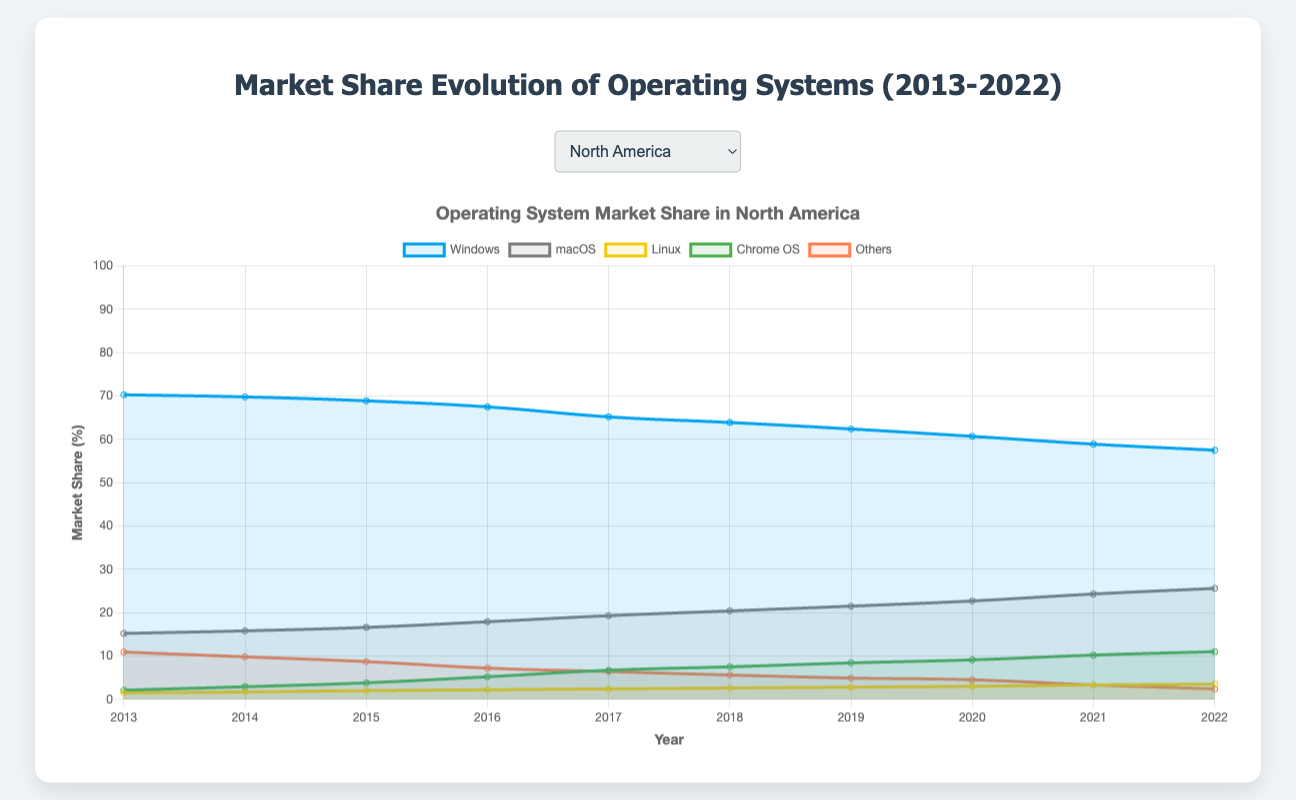What is the overall trend for Windows market share in North America from 2013 to 2022? The Windows market share in North America shows a consistent decline over the years. Starting at 70.3% in 2013 and decreasing to 57.5% in 2022. This indicates an overall downward trend.
Answer: Downward Which region had the highest market share for macOS in 2022? To find the region with the highest macOS market share in 2022, we compare the values across regions: North America (25.6%), Europe (18.9%), Asia-Pacific (9.7%), Latin America (13.1%), and Middle East & Africa (10.5%). North America has the highest share.
Answer: North America Compare the market share of Chrome OS in North America and Europe in 2017. Which region has a higher share? Chrome OS in North America has a market share of 6.7% in 2017, while Europe has a market share of 3.3%. Thus, North America has a higher share.
Answer: North America What is the combined market share of Linux and macOS in Asia-Pacific in 2022? Linux has a market share of 3.9% and macOS has 9.7% in Asia-Pacific for 2022. Adding these together gives 3.9% + 9.7% = 13.6%.
Answer: 13.6% Which operating system had the largest increase in market share in North America from 2013 to 2022? Comparing the market share changes for each OS in North America from 2013 to 2022: Windows (-12.8%), macOS (+10.4%), Linux (+2.0%), Chrome OS (+8.9%), Others (-8.5%). macOS saw the largest increase.
Answer: macOS In 2022, at what rate has the "Others" category decreased in North America compared to 2013? "Others" had a market share of 10.9% in 2013 and 2.4% in 2022 in North America. The decrease is 10.9% - 2.4% = 8.5%.
Answer: 8.5% Which operating system had the most stable market share (least change) in Latin America from 2013 to 2022? By calculating the differences for each OS in Latin America from 2013 to 2022: Windows (-13.4%), Linux (+2.9%), macOS (+7.1%), Chrome OS (+6.1%), Others (-2.7%). Linux had the smallest change (+2.9%).
Answer: Linux Compare the trend of Windows market share in Asia-Pacific and Europe from 2013 to 2022. What is common? Both Asia-Pacific and Europe show a declining trend for Windows market share from 2013 to 2022. In Asia-Pacific, it decreased from 80.6% to 63.0%, and in Europe, it decreased from 75.1% to 62.1%. The commonality is the downward trend.
Answer: Downward trend What is the difference in market share between Windows and Android in Asia-Pacific in 2022? The market share of Windows in Asia-Pacific in 2022 is 63.0% and for Android, it is 22.9%. The difference is 63.0% - 22.9% = 40.1%.
Answer: 40.1% How did the market share for "Others" category in Middle East & Africa change from 2013 to 2022? "Others" category in Middle East & Africa had a market share of 13.1% in 2013 and 16.4% in 2022. The difference is 16.4% - 13.1% = 3.3%, indicating an increase.
Answer: 3.3% 